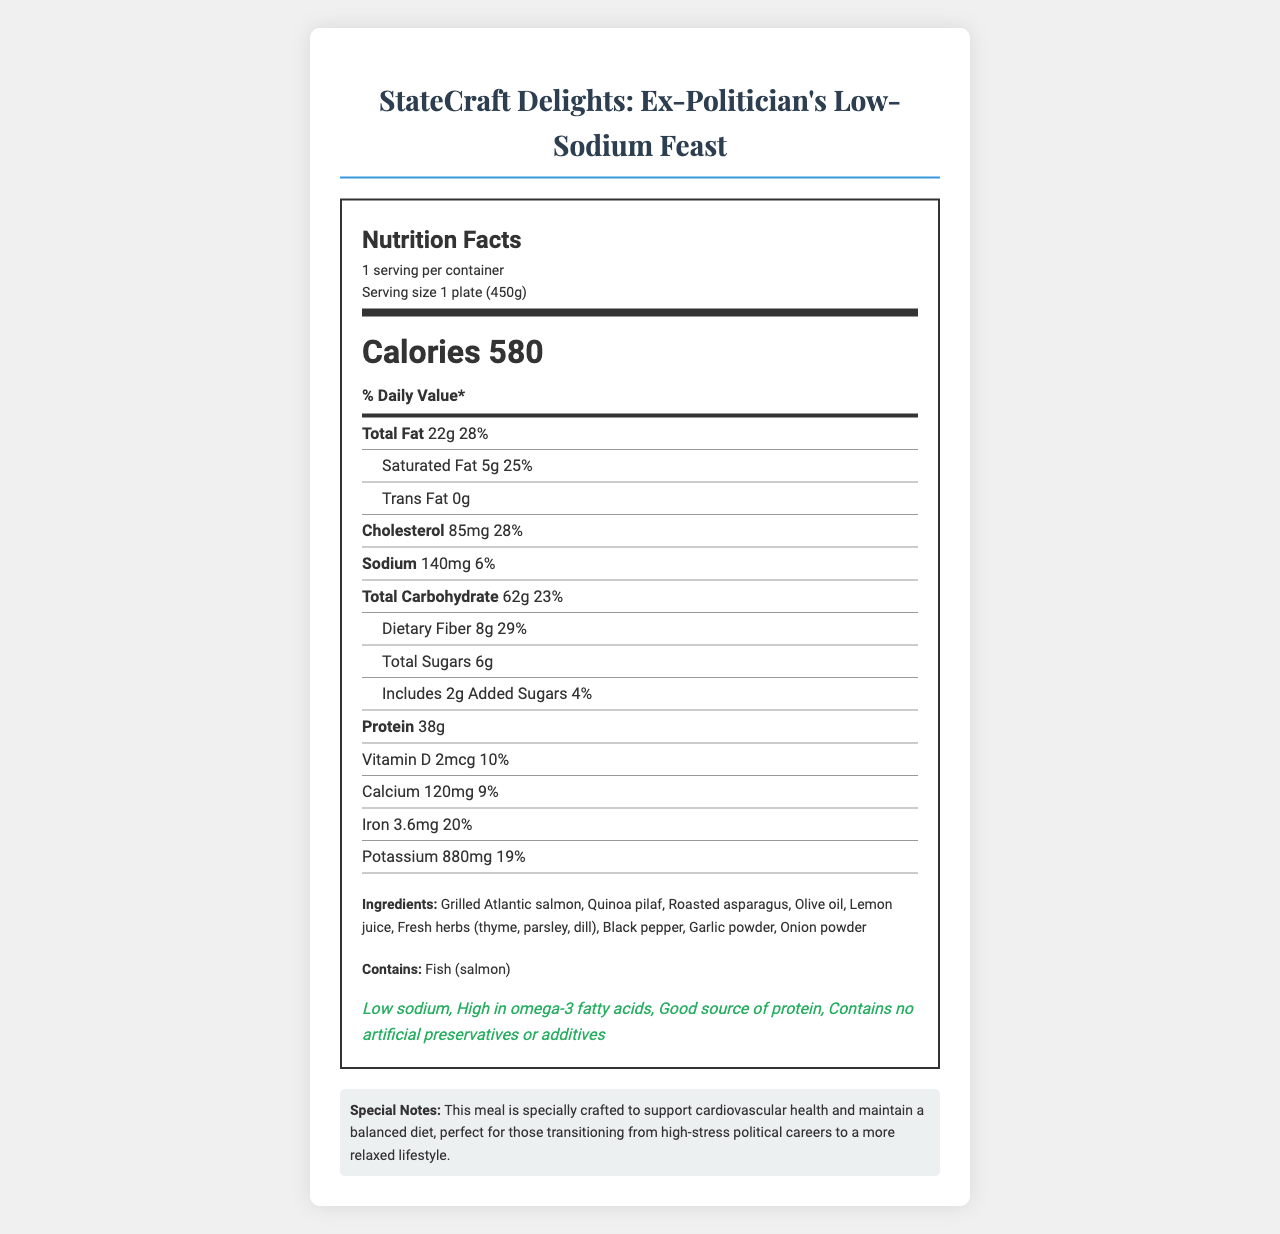what is the serving size of the meal? The serving size is presented at the top of the nutrition label under the "serving size" section.
Answer: 1 plate (450g) how many calories are in one serving of StateCraft Delights? The document lists "Calories 580" in a prominent section of the nutrition label.
Answer: 580 calories what is the amount of total fat per serving, and what percentage of the daily value does it represent? The nutrition label under "Total Fat" states that it is 22g and this represents 28% of the daily value.
Answer: 22g, 28% how much dietary fiber is in one serving? The nutrition label under "Dietary Fiber" states there are 8g of dietary fiber.
Answer: 8g which ingredient in the meal is listed as an allergen? The allergen section of the document indicates the meal contains "Fish (salmon)."
Answer: Fish (salmon) which of the following health claims is NOT listed for the meal? A. Low sodium B. High in omega-3 fatty acids C. Low calorie D. Good source of protein The health claims section includes "Low sodium", "High in omega-3 fatty acids", and "Good source of protein", but mentions nothing about being "Low calorie".
Answer: C. Low calorie how much sodium is in one serving? A. 140mg B. 180mg C. 200mg D. 240mg The nutrition label explicitly states "Sodium 140mg" under the sodium section.
Answer: A. 140mg Is this meal suitable for storage? The document states "Best consumed immediately. Not suitable for storage" in the shelf life section.
Answer: No summarize the main idea of the document. The primary aim of the document is to inform potential consumers about the nutritional content, ingredients, and special considerations for consuming the luxurious, health-conscious meal.
Answer: The document presents the nutrition facts for "StateCraft Delights: Ex-Politician's Low-Sodium Feast," detailing the serving size, calories, various nutrients, ingredients, allergens, health claims, preparation standards, and special notes for former political figures. what is the daily value percentage for calcium based on the document? The nutrition label specifies "Calcium 120mg" and its corresponding daily value percentage is 9%.
Answer: 9% what are the health claims listed for the meal? The health claims section of the document lists these benefits explicitly.
Answer: Low sodium, High in omega-3 fatty acids, Good source of protein, Contains no artificial preservatives or additives what preparation standards are mentioned for the meal? The document mentions that the meal is "Prepared in a kitchen that adheres to strict hygiene standards, as befitting a meal for former political figures."
Answer: Prepared in a kitchen that adheres to strict hygiene standards what are the potential benefits of this meal to someone with a history of high-stress political careers? According to the special notes section, the meal supports cardiovascular health and helps maintain a balanced diet.
Answer: Supports cardiovascular health and maintains a balanced diet what is the source of protein in the meal? The ingredients list includes "Grilled Atlantic salmon," which is a rich source of protein.
Answer: Grilled Atlantic salmon what portion of the daily iron requirement does one serving fulfill? The nutrition label specifies "Iron 3.6mg" with a 20% daily value.
Answer: 20% is this meal high in saturated fat? The meal contains 5g of saturated fat which constitutes 25% of the daily value, not typically considered high compared to daily needs.
Answer: No how many added sugars are in one serving? The document mentions "Includes 2g Added Sugars” in the nutrition facts label.
Answer: 2g does the nutrition label specify the amount of magnesium in the meal? The document does not mention magnesium anywhere in the nutrition facts label.
Answer: No 